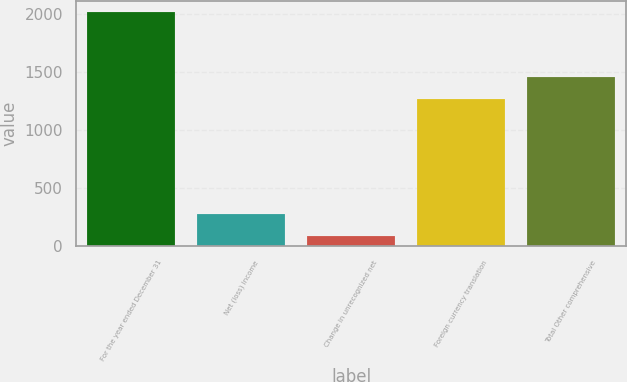Convert chart. <chart><loc_0><loc_0><loc_500><loc_500><bar_chart><fcel>For the year ended December 31<fcel>Net (loss) income<fcel>Change in unrecognized net<fcel>Foreign currency translation<fcel>Total Other comprehensive<nl><fcel>2014<fcel>275.2<fcel>82<fcel>1266<fcel>1459.2<nl></chart> 